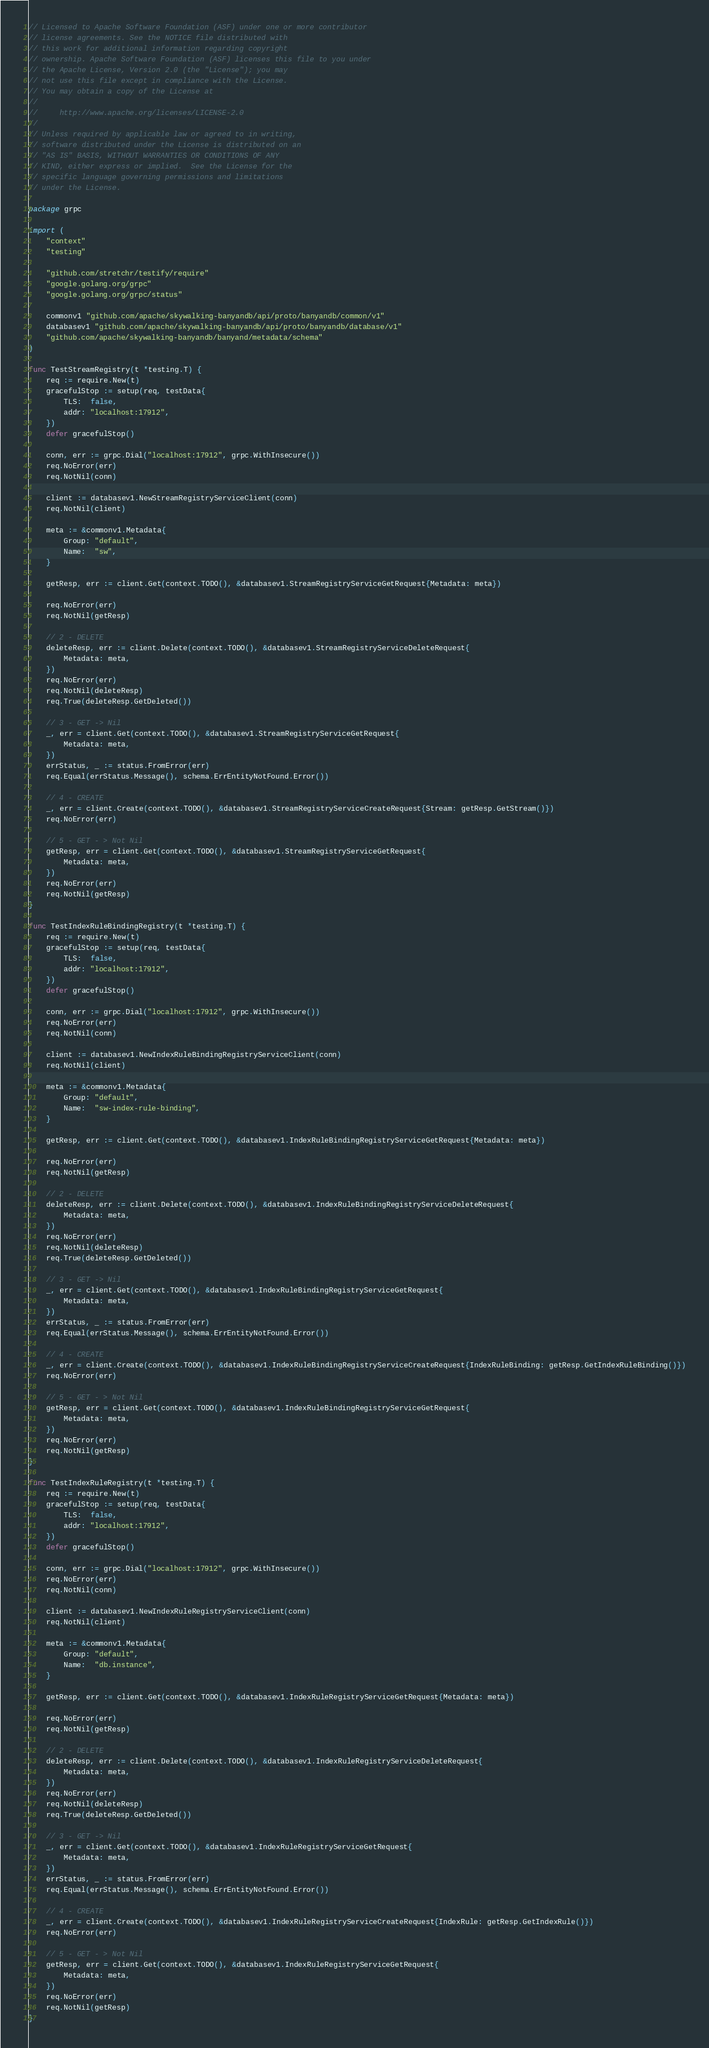<code> <loc_0><loc_0><loc_500><loc_500><_Go_>// Licensed to Apache Software Foundation (ASF) under one or more contributor
// license agreements. See the NOTICE file distributed with
// this work for additional information regarding copyright
// ownership. Apache Software Foundation (ASF) licenses this file to you under
// the Apache License, Version 2.0 (the "License"); you may
// not use this file except in compliance with the License.
// You may obtain a copy of the License at
//
//     http://www.apache.org/licenses/LICENSE-2.0
//
// Unless required by applicable law or agreed to in writing,
// software distributed under the License is distributed on an
// "AS IS" BASIS, WITHOUT WARRANTIES OR CONDITIONS OF ANY
// KIND, either express or implied.  See the License for the
// specific language governing permissions and limitations
// under the License.

package grpc

import (
	"context"
	"testing"

	"github.com/stretchr/testify/require"
	"google.golang.org/grpc"
	"google.golang.org/grpc/status"

	commonv1 "github.com/apache/skywalking-banyandb/api/proto/banyandb/common/v1"
	databasev1 "github.com/apache/skywalking-banyandb/api/proto/banyandb/database/v1"
	"github.com/apache/skywalking-banyandb/banyand/metadata/schema"
)

func TestStreamRegistry(t *testing.T) {
	req := require.New(t)
	gracefulStop := setup(req, testData{
		TLS:  false,
		addr: "localhost:17912",
	})
	defer gracefulStop()

	conn, err := grpc.Dial("localhost:17912", grpc.WithInsecure())
	req.NoError(err)
	req.NotNil(conn)

	client := databasev1.NewStreamRegistryServiceClient(conn)
	req.NotNil(client)

	meta := &commonv1.Metadata{
		Group: "default",
		Name:  "sw",
	}

	getResp, err := client.Get(context.TODO(), &databasev1.StreamRegistryServiceGetRequest{Metadata: meta})

	req.NoError(err)
	req.NotNil(getResp)

	// 2 - DELETE
	deleteResp, err := client.Delete(context.TODO(), &databasev1.StreamRegistryServiceDeleteRequest{
		Metadata: meta,
	})
	req.NoError(err)
	req.NotNil(deleteResp)
	req.True(deleteResp.GetDeleted())

	// 3 - GET -> Nil
	_, err = client.Get(context.TODO(), &databasev1.StreamRegistryServiceGetRequest{
		Metadata: meta,
	})
	errStatus, _ := status.FromError(err)
	req.Equal(errStatus.Message(), schema.ErrEntityNotFound.Error())

	// 4 - CREATE
	_, err = client.Create(context.TODO(), &databasev1.StreamRegistryServiceCreateRequest{Stream: getResp.GetStream()})
	req.NoError(err)

	// 5 - GET - > Not Nil
	getResp, err = client.Get(context.TODO(), &databasev1.StreamRegistryServiceGetRequest{
		Metadata: meta,
	})
	req.NoError(err)
	req.NotNil(getResp)
}

func TestIndexRuleBindingRegistry(t *testing.T) {
	req := require.New(t)
	gracefulStop := setup(req, testData{
		TLS:  false,
		addr: "localhost:17912",
	})
	defer gracefulStop()

	conn, err := grpc.Dial("localhost:17912", grpc.WithInsecure())
	req.NoError(err)
	req.NotNil(conn)

	client := databasev1.NewIndexRuleBindingRegistryServiceClient(conn)
	req.NotNil(client)

	meta := &commonv1.Metadata{
		Group: "default",
		Name:  "sw-index-rule-binding",
	}

	getResp, err := client.Get(context.TODO(), &databasev1.IndexRuleBindingRegistryServiceGetRequest{Metadata: meta})

	req.NoError(err)
	req.NotNil(getResp)

	// 2 - DELETE
	deleteResp, err := client.Delete(context.TODO(), &databasev1.IndexRuleBindingRegistryServiceDeleteRequest{
		Metadata: meta,
	})
	req.NoError(err)
	req.NotNil(deleteResp)
	req.True(deleteResp.GetDeleted())

	// 3 - GET -> Nil
	_, err = client.Get(context.TODO(), &databasev1.IndexRuleBindingRegistryServiceGetRequest{
		Metadata: meta,
	})
	errStatus, _ := status.FromError(err)
	req.Equal(errStatus.Message(), schema.ErrEntityNotFound.Error())

	// 4 - CREATE
	_, err = client.Create(context.TODO(), &databasev1.IndexRuleBindingRegistryServiceCreateRequest{IndexRuleBinding: getResp.GetIndexRuleBinding()})
	req.NoError(err)

	// 5 - GET - > Not Nil
	getResp, err = client.Get(context.TODO(), &databasev1.IndexRuleBindingRegistryServiceGetRequest{
		Metadata: meta,
	})
	req.NoError(err)
	req.NotNil(getResp)
}

func TestIndexRuleRegistry(t *testing.T) {
	req := require.New(t)
	gracefulStop := setup(req, testData{
		TLS:  false,
		addr: "localhost:17912",
	})
	defer gracefulStop()

	conn, err := grpc.Dial("localhost:17912", grpc.WithInsecure())
	req.NoError(err)
	req.NotNil(conn)

	client := databasev1.NewIndexRuleRegistryServiceClient(conn)
	req.NotNil(client)

	meta := &commonv1.Metadata{
		Group: "default",
		Name:  "db.instance",
	}

	getResp, err := client.Get(context.TODO(), &databasev1.IndexRuleRegistryServiceGetRequest{Metadata: meta})

	req.NoError(err)
	req.NotNil(getResp)

	// 2 - DELETE
	deleteResp, err := client.Delete(context.TODO(), &databasev1.IndexRuleRegistryServiceDeleteRequest{
		Metadata: meta,
	})
	req.NoError(err)
	req.NotNil(deleteResp)
	req.True(deleteResp.GetDeleted())

	// 3 - GET -> Nil
	_, err = client.Get(context.TODO(), &databasev1.IndexRuleRegistryServiceGetRequest{
		Metadata: meta,
	})
	errStatus, _ := status.FromError(err)
	req.Equal(errStatus.Message(), schema.ErrEntityNotFound.Error())

	// 4 - CREATE
	_, err = client.Create(context.TODO(), &databasev1.IndexRuleRegistryServiceCreateRequest{IndexRule: getResp.GetIndexRule()})
	req.NoError(err)

	// 5 - GET - > Not Nil
	getResp, err = client.Get(context.TODO(), &databasev1.IndexRuleRegistryServiceGetRequest{
		Metadata: meta,
	})
	req.NoError(err)
	req.NotNil(getResp)
}
</code> 